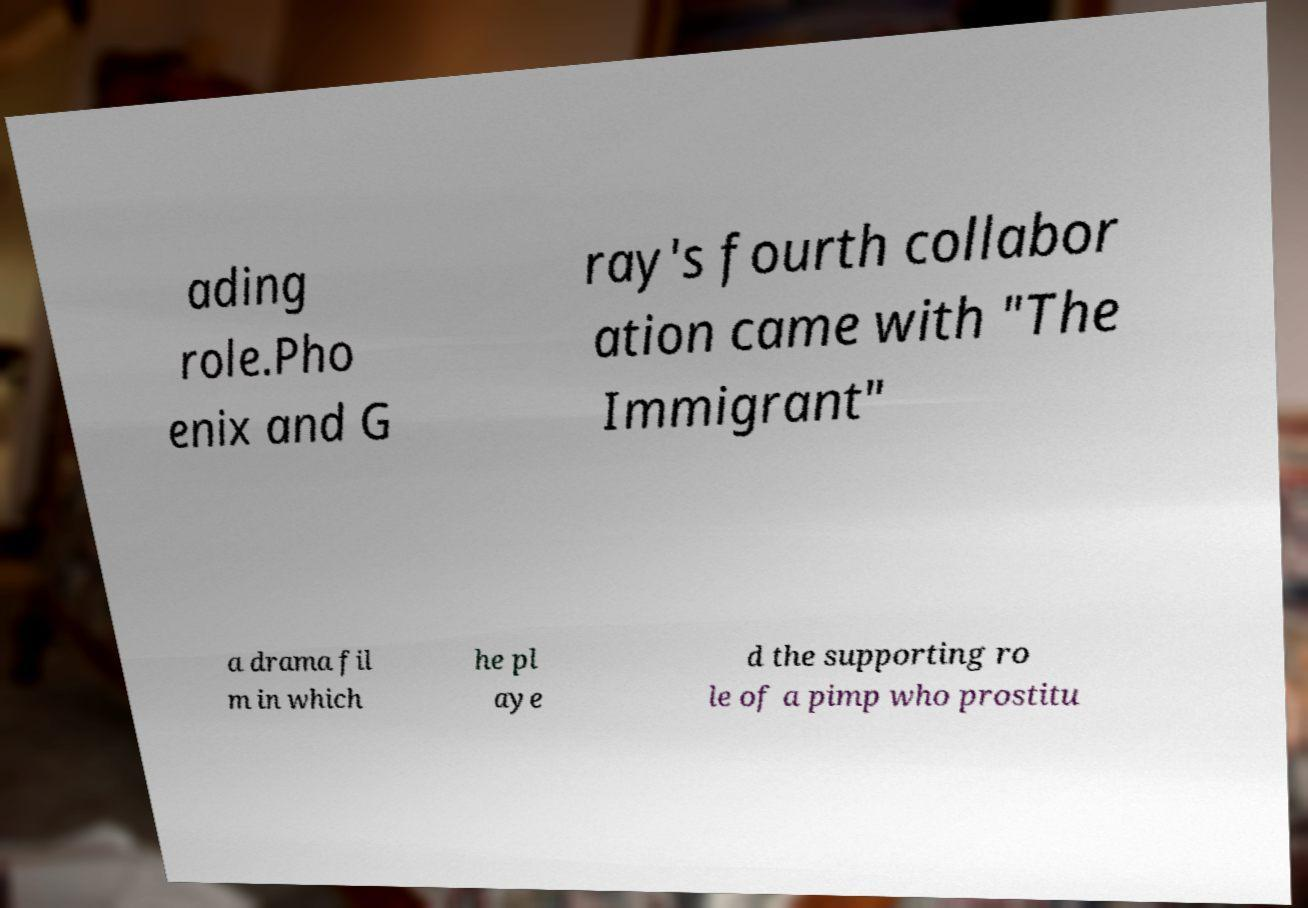Can you accurately transcribe the text from the provided image for me? ading role.Pho enix and G ray's fourth collabor ation came with "The Immigrant" a drama fil m in which he pl aye d the supporting ro le of a pimp who prostitu 